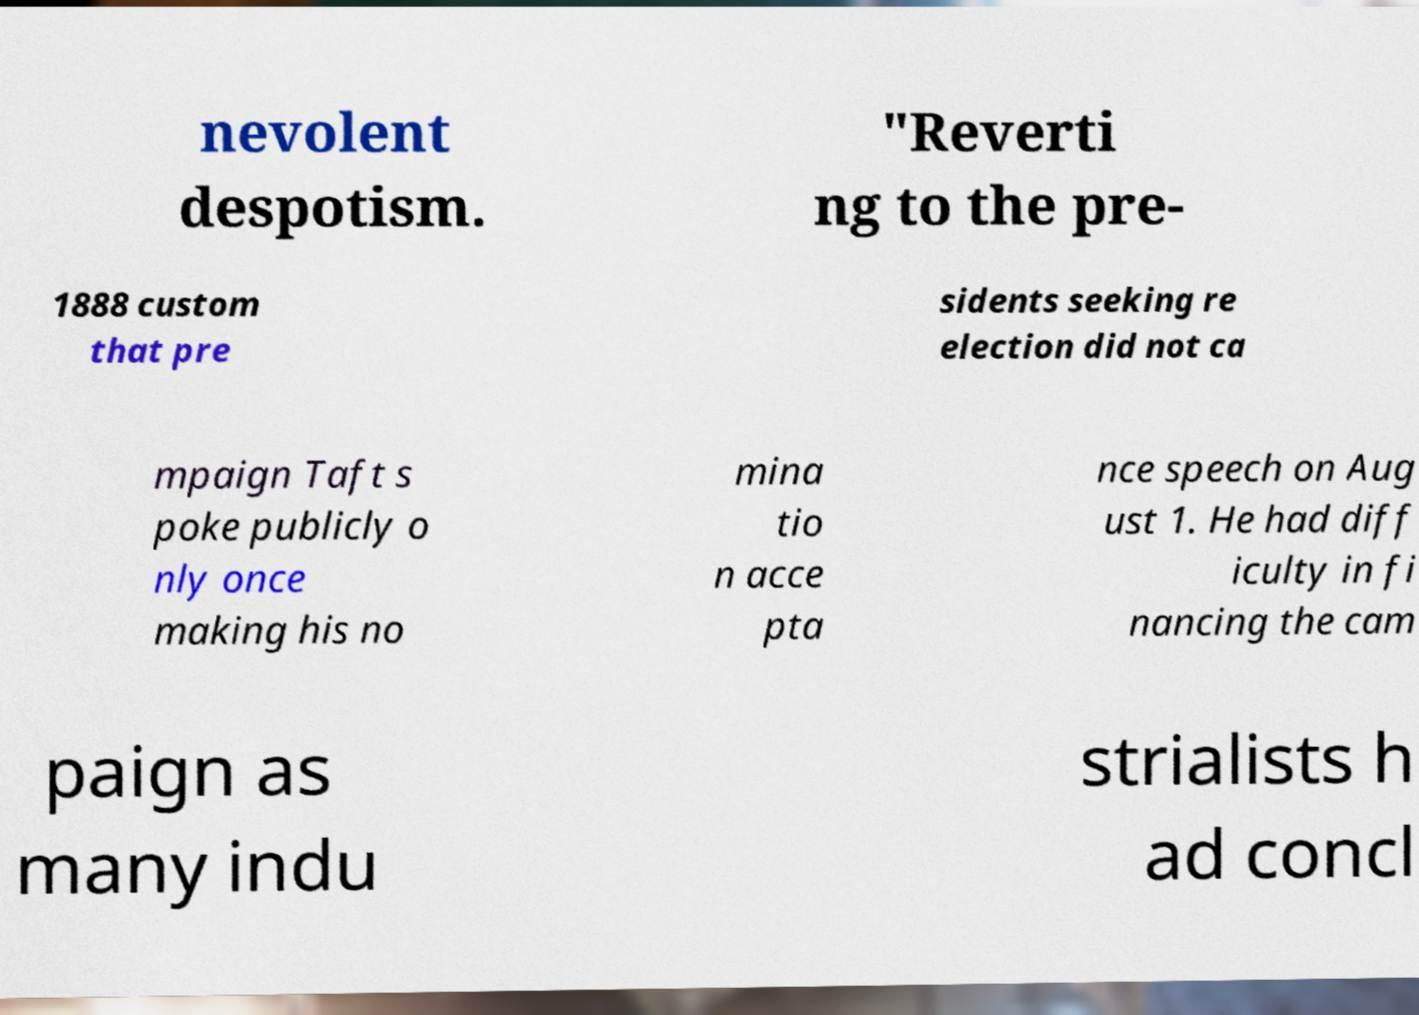Could you assist in decoding the text presented in this image and type it out clearly? nevolent despotism. "Reverti ng to the pre- 1888 custom that pre sidents seeking re election did not ca mpaign Taft s poke publicly o nly once making his no mina tio n acce pta nce speech on Aug ust 1. He had diff iculty in fi nancing the cam paign as many indu strialists h ad concl 